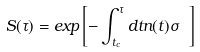Convert formula to latex. <formula><loc_0><loc_0><loc_500><loc_500>S ( \tau ) = e x p \left [ - \int _ { t _ { c } } ^ { \tau } d t n ( t ) \sigma \ \right ]</formula> 